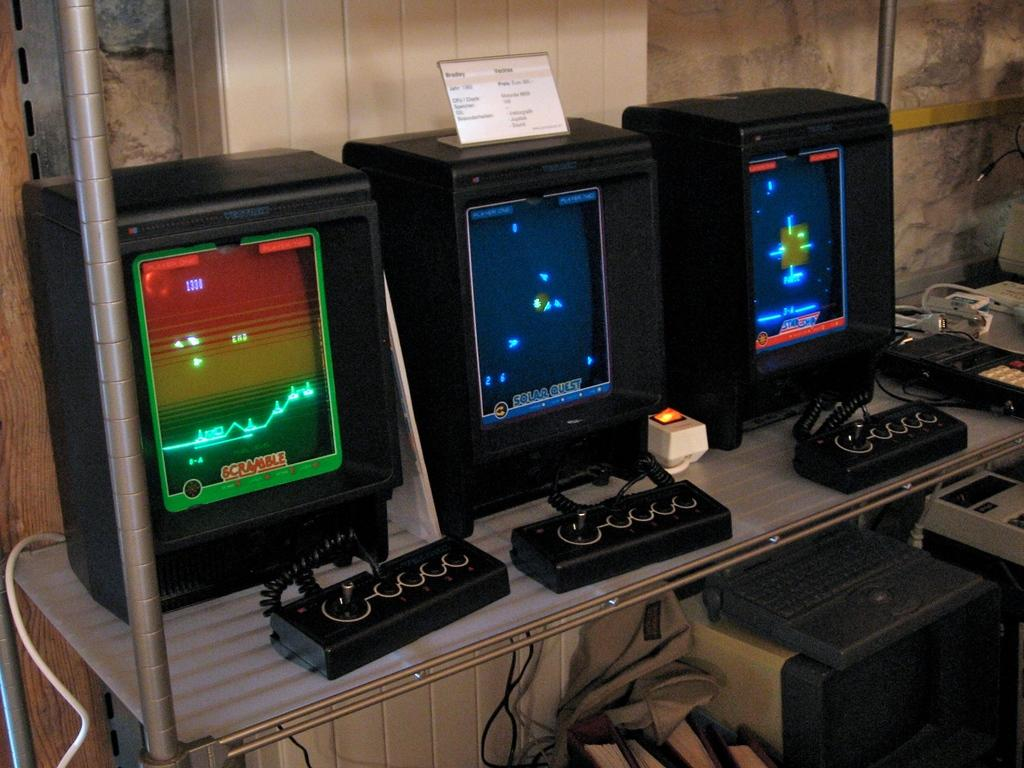<image>
Render a clear and concise summary of the photo. A game called Scramble is pulled up on an old video game display. 